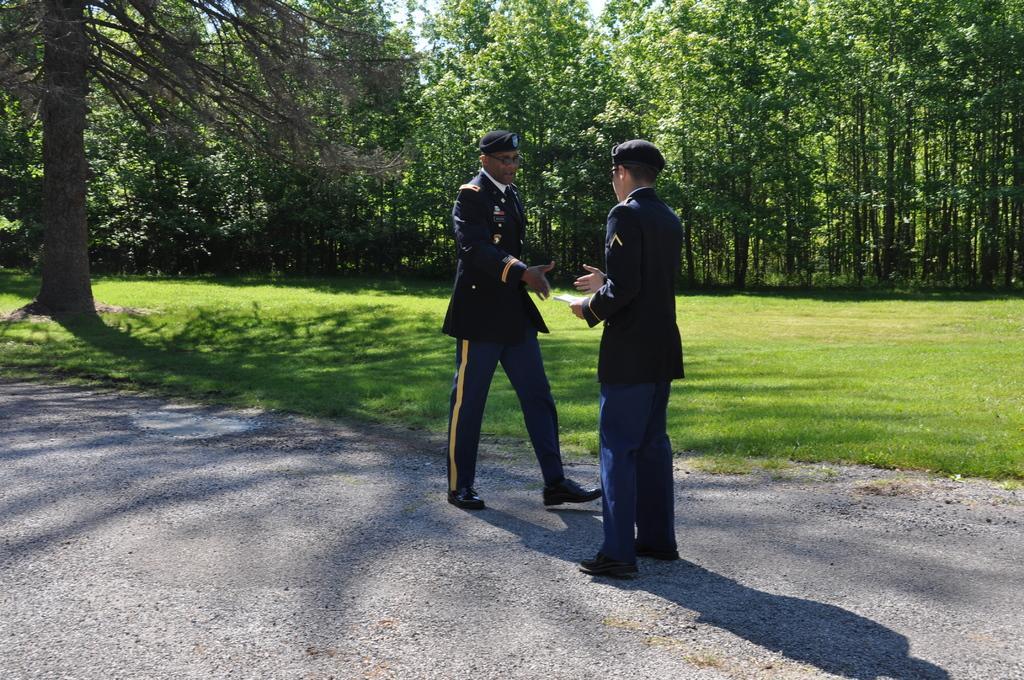Could you give a brief overview of what you see in this image? In the image there are two officers shaking hands and behind them there are trees on the grassland. 